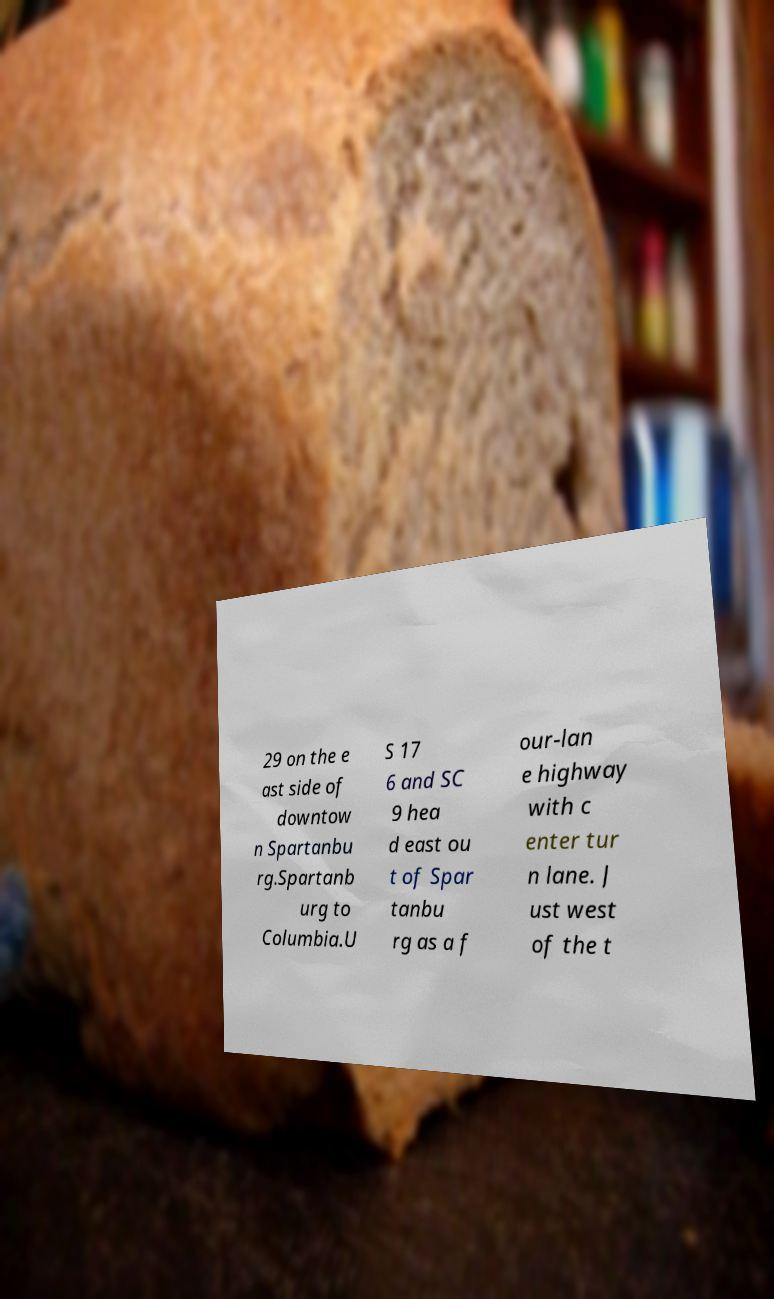Can you read and provide the text displayed in the image?This photo seems to have some interesting text. Can you extract and type it out for me? 29 on the e ast side of downtow n Spartanbu rg.Spartanb urg to Columbia.U S 17 6 and SC 9 hea d east ou t of Spar tanbu rg as a f our-lan e highway with c enter tur n lane. J ust west of the t 